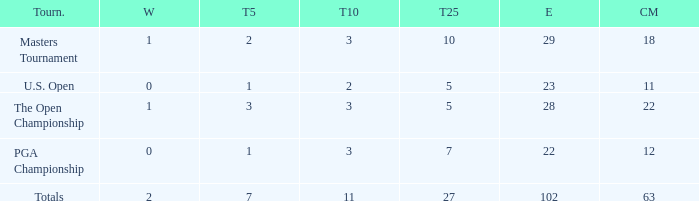How many top 10s when he had under 1 top 5s? None. 